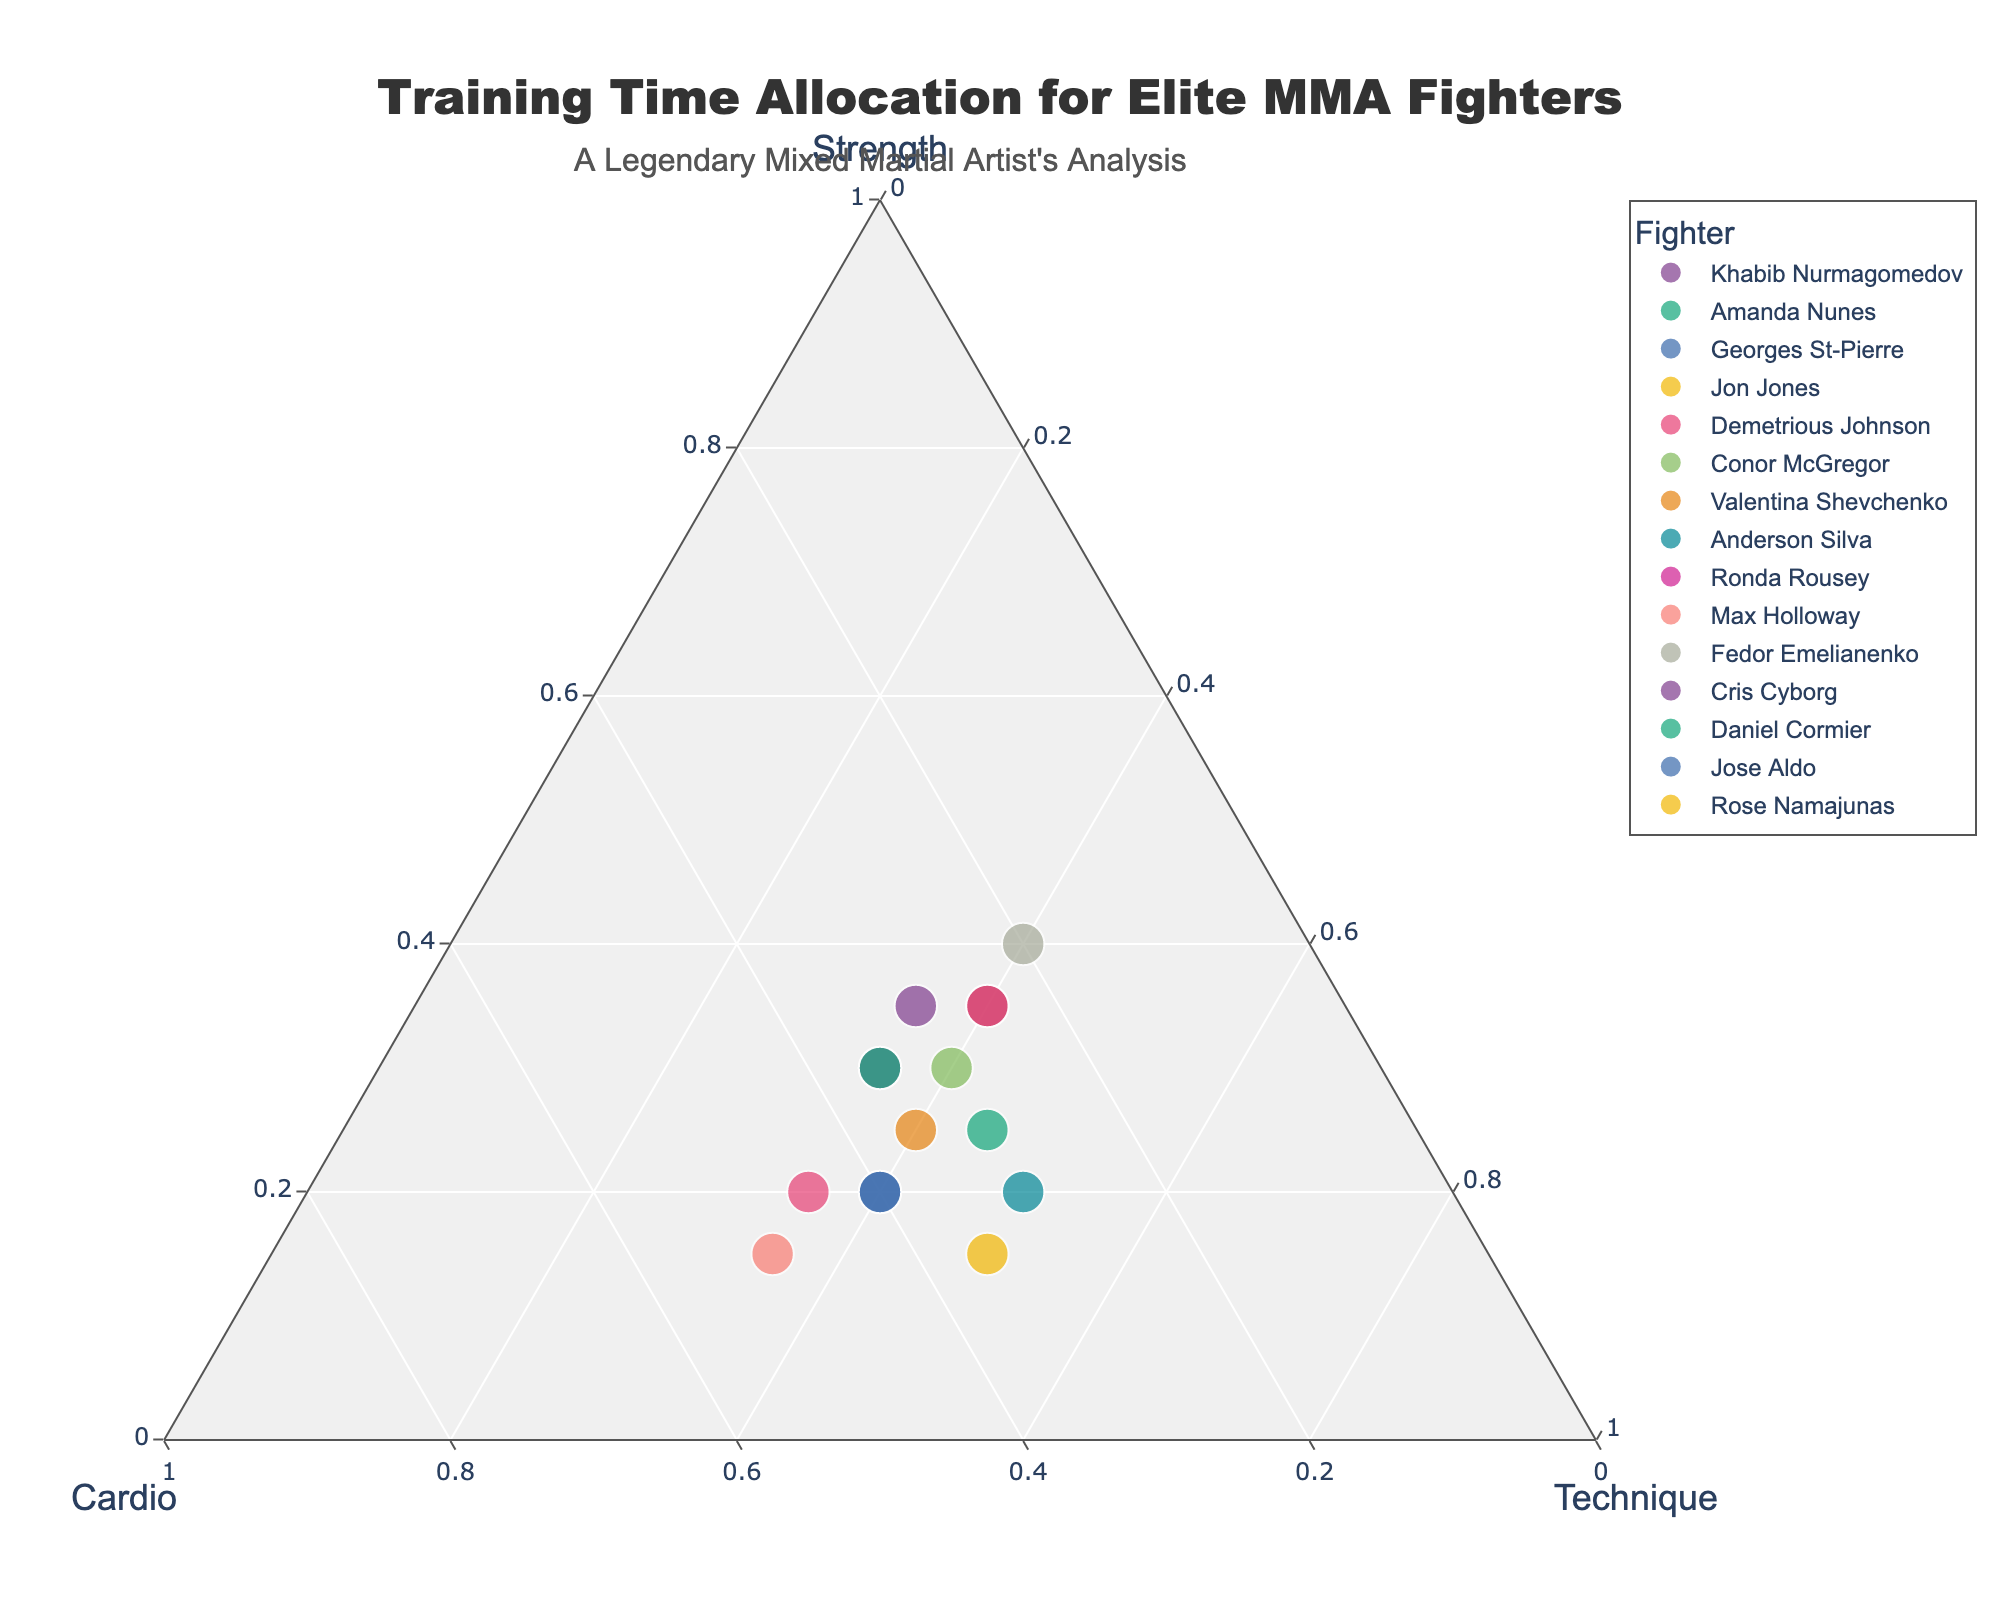Which fighter allocates the most time to Technique work? By examining the plot, find the point closest to the Technique axis corner. This fighter allocates the highest percentage towards Technique.
Answer: Anderson Silva How many fighters allocate exactly 35% of their training to Strength? Look for the points lying on the 35% Strength axis to count the number of fighters meeting this criterion.
Answer: 3 Which fighter has the highest allocation in Cardio? Look for the point closest to the Cardio corner on the ternary plot. This point represents the fighter with the highest allocation to Cardio.
Answer: Max Holloway What is the total training time percentage allocated to Strength and Cardio for Jon Jones? Identify Jon Jones' position and sum his allocation to Strength and Cardio: 35% (Strength) + 25% (Cardio).
Answer: 60% Who has an equal allocation between Cardio and Technique, and what is this percentage? Find the point where the values for Cardio and Technique are the same, indicating equal allocation between the two.
Answer: Georges St-Pierre and Jose Aldo with 40% Which two fighters have the same allocation for all three training components, and what are these values? Identify fighters with identical coordinates in Strength, Cardio, and Technique on the plot.
Answer: Khabib Nurmagomedov and Daniel Cormier with 30%, 35%, 35% What is the average allocation to Technique across all fighters shown in the plot? Sum up the Technique percentages across all fighters and divide by the number of fighters: (35 + 45 + 40 + 40 + 35 + 40 + 40 + 50 + 40 + 35 + 40 + 35 + 35 + 40 + 50) / 15 = 38.33%.
Answer: 38.33% Which fighter pairs have the same Technique allocation but different Strength allocations, and what are these values? Look for pairs of points with identical Technique values but different Strength values.
Answer: Jon Jones and Conor McGregor with Technique 40% but different Strength (35%, 30%) Compare Fedor Emelianenko and Rose Namajunas: who allocates more time to Cardio, and by how much? Subtract Rose Namajunas’ Cardio percentage from Fedor Emelianenko’s. Fedor's Cardio is 20% and Rose's is 35%, so: 35% - 20% = 15%.
Answer: Rose Namajunas by 15% Which fighter devotes the most balanced time among Strength, Cardio, and Technique? Identify the fighter whose coordinates are closest to the center of the ternary plot.
Answer: Khabib Nurmagomedov and Daniel Cormier 